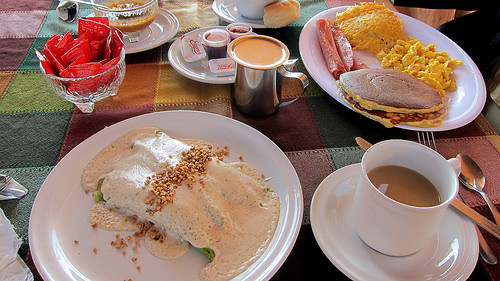<image>
Can you confirm if the food is on the table? Yes. Looking at the image, I can see the food is positioned on top of the table, with the table providing support. 